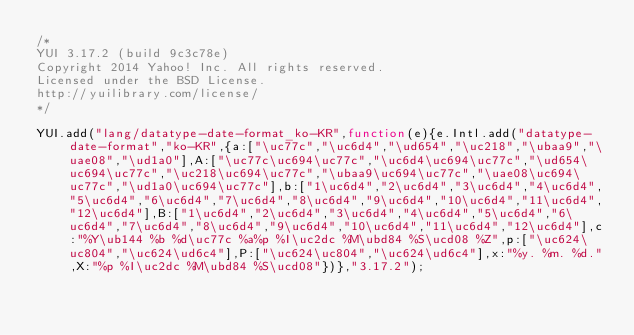Convert code to text. <code><loc_0><loc_0><loc_500><loc_500><_JavaScript_>/*
YUI 3.17.2 (build 9c3c78e)
Copyright 2014 Yahoo! Inc. All rights reserved.
Licensed under the BSD License.
http://yuilibrary.com/license/
*/

YUI.add("lang/datatype-date-format_ko-KR",function(e){e.Intl.add("datatype-date-format","ko-KR",{a:["\uc77c","\uc6d4","\ud654","\uc218","\ubaa9","\uae08","\ud1a0"],A:["\uc77c\uc694\uc77c","\uc6d4\uc694\uc77c","\ud654\uc694\uc77c","\uc218\uc694\uc77c","\ubaa9\uc694\uc77c","\uae08\uc694\uc77c","\ud1a0\uc694\uc77c"],b:["1\uc6d4","2\uc6d4","3\uc6d4","4\uc6d4","5\uc6d4","6\uc6d4","7\uc6d4","8\uc6d4","9\uc6d4","10\uc6d4","11\uc6d4","12\uc6d4"],B:["1\uc6d4","2\uc6d4","3\uc6d4","4\uc6d4","5\uc6d4","6\uc6d4","7\uc6d4","8\uc6d4","9\uc6d4","10\uc6d4","11\uc6d4","12\uc6d4"],c:"%Y\ub144 %b %d\uc77c %a%p %I\uc2dc %M\ubd84 %S\ucd08 %Z",p:["\uc624\uc804","\uc624\ud6c4"],P:["\uc624\uc804","\uc624\ud6c4"],x:"%y. %m. %d.",X:"%p %I\uc2dc %M\ubd84 %S\ucd08"})},"3.17.2");
</code> 